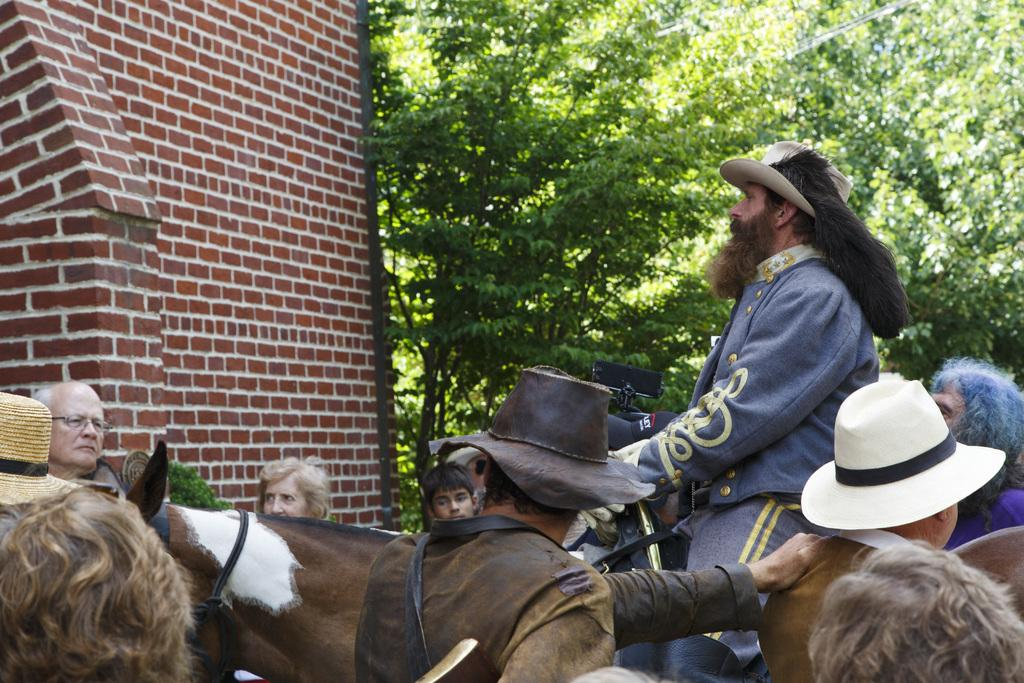What animal is present in the image? There is a horse in the image. Are there any people in the image? Yes, there are people in the image. What are some people doing in relation to the horse? Some people are near the horse, and one person is sitting on the horse. Can you describe the attire of some people in the image? Some people are wearing hats. What type of vegetation can be seen in the image? There are trees in the image. What type of structure is visible in the image? There is a brick wall in the image. Can you describe the unspecified object in the image? Unfortunately, the facts provided do not give any details about the unspecified object. How many dogs are present in the image? There are no dogs mentioned or visible in the image. What is the process for training the horse in the image? The provided facts do not give any information about training the horse, so we cannot determine the process from the image. 